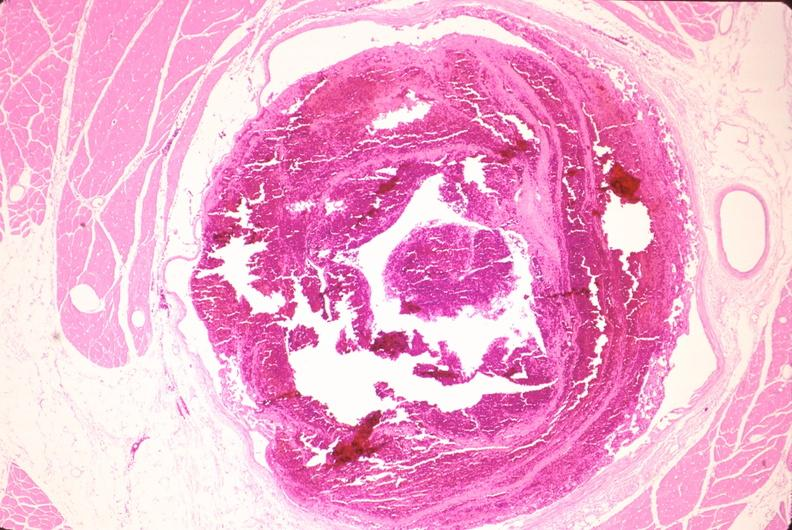s vasculature present?
Answer the question using a single word or phrase. Yes 